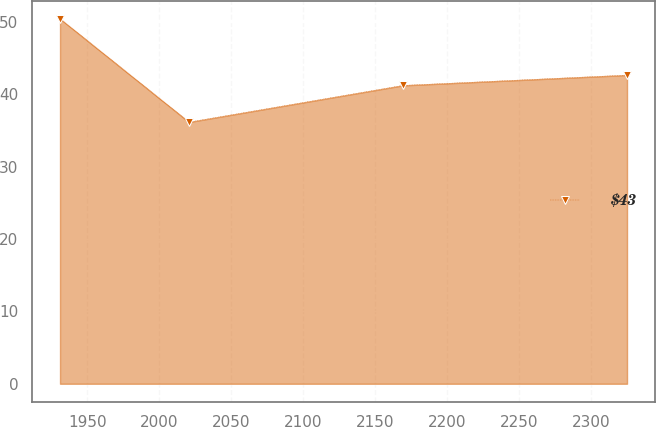Convert chart. <chart><loc_0><loc_0><loc_500><loc_500><line_chart><ecel><fcel>$43<nl><fcel>1931.05<fcel>50.46<nl><fcel>2020.64<fcel>36.18<nl><fcel>2169.13<fcel>41.25<nl><fcel>2324.89<fcel>42.68<nl></chart> 